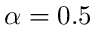Convert formula to latex. <formula><loc_0><loc_0><loc_500><loc_500>\alpha = 0 . 5</formula> 